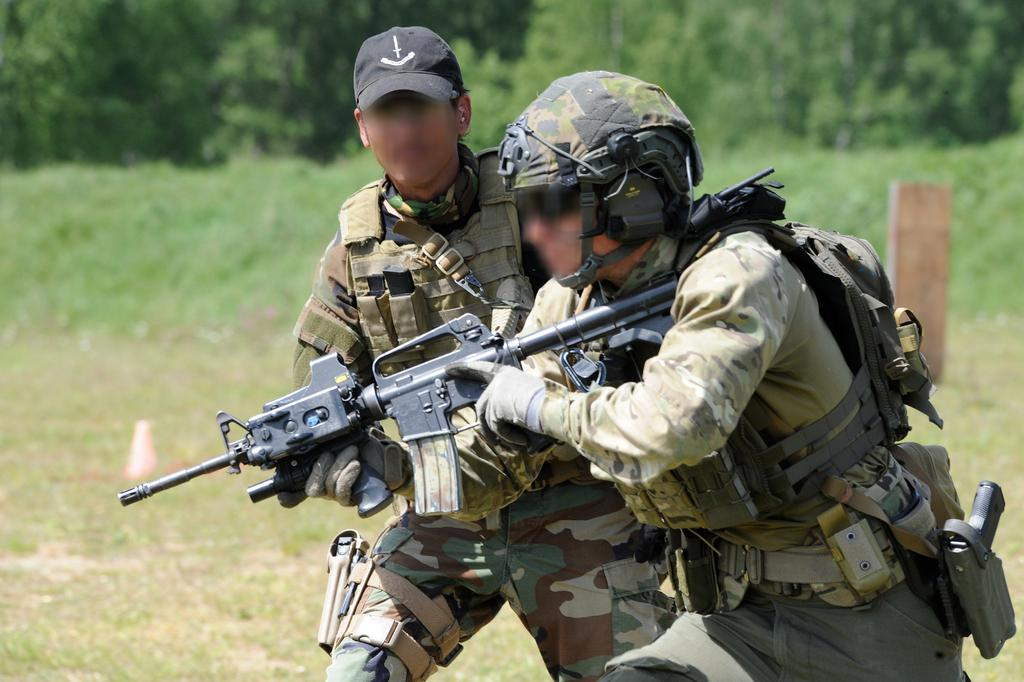How many men are in the image? There are two men in the image. What are the men wearing on their bodies? The men are wearing bags and helmets. What are the men holding in their hands? The men are holding guns. What can be seen in the background of the image? There is a pole, plants, and a group of trees visible in the image. What type of yarn is being used to create the collars on the men's shirts in the image? There is no yarn or collars visible on the men's shirts in the image. What mathematical operation is being performed by the men in the image? There is no indication of any mathematical operation being performed by the men in the image. 